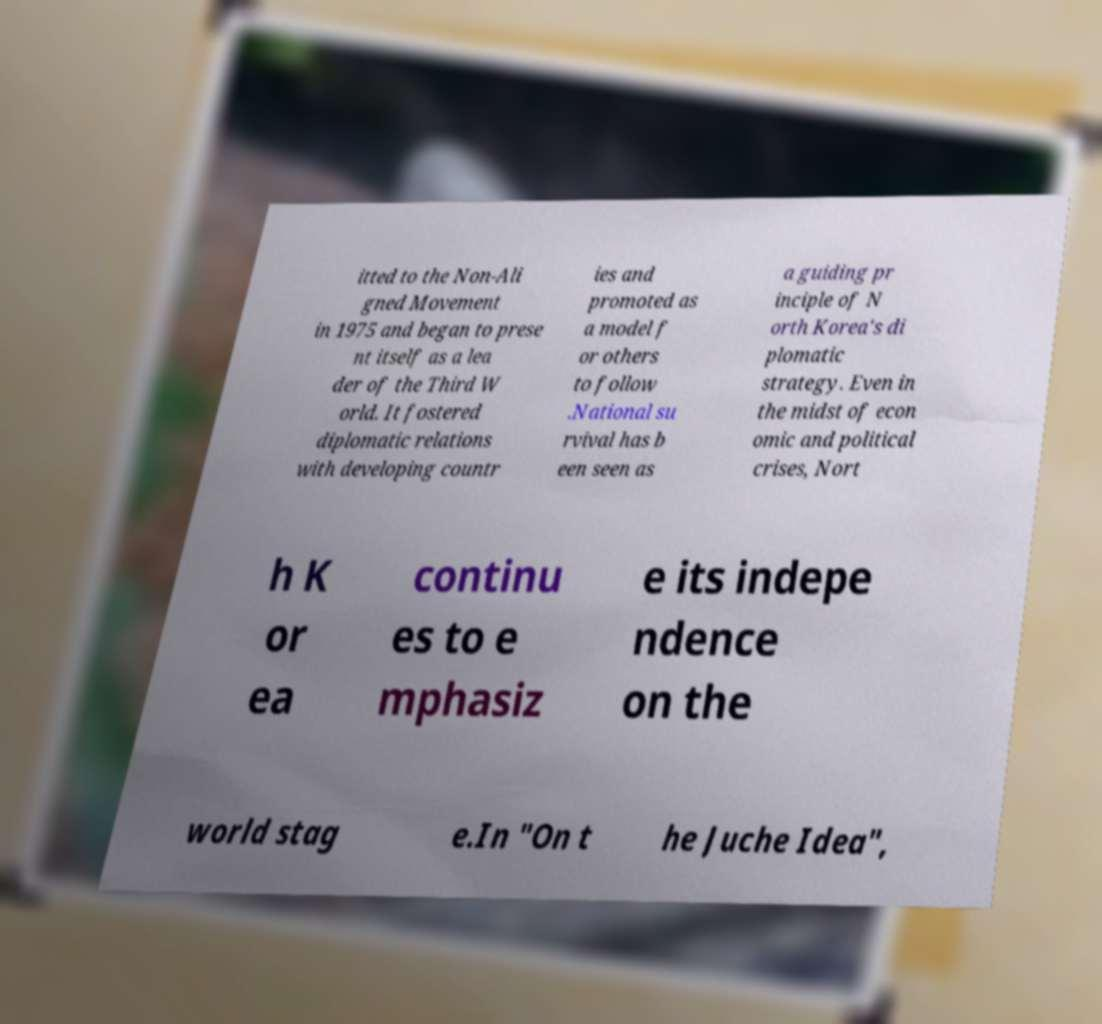Please identify and transcribe the text found in this image. itted to the Non-Ali gned Movement in 1975 and began to prese nt itself as a lea der of the Third W orld. It fostered diplomatic relations with developing countr ies and promoted as a model f or others to follow .National su rvival has b een seen as a guiding pr inciple of N orth Korea's di plomatic strategy. Even in the midst of econ omic and political crises, Nort h K or ea continu es to e mphasiz e its indepe ndence on the world stag e.In "On t he Juche Idea", 